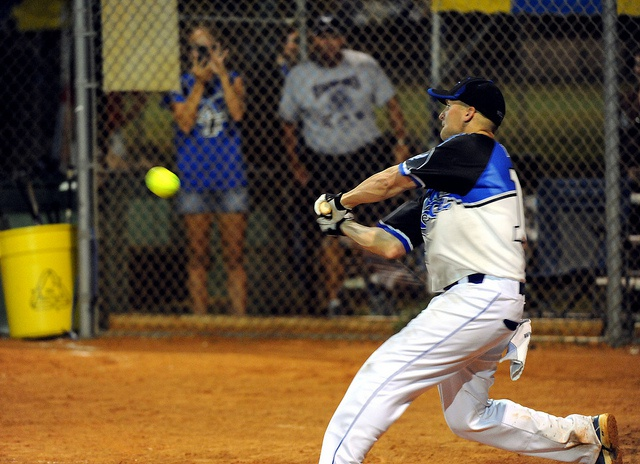Describe the objects in this image and their specific colors. I can see people in black, white, darkgray, and gray tones, people in black, gray, and maroon tones, people in black, navy, and maroon tones, bench in black and gray tones, and sports ball in black, yellow, olive, and khaki tones in this image. 